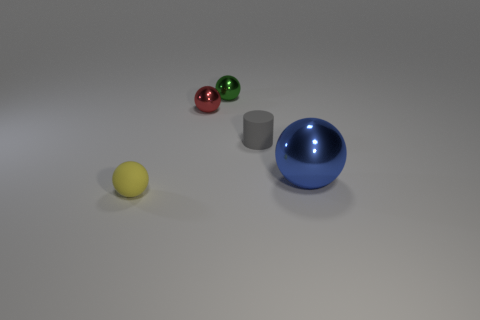There is a object that is in front of the tiny green ball and behind the small gray rubber thing; what is its shape?
Offer a terse response. Sphere. Is there a blue shiny sphere that has the same size as the red metallic sphere?
Keep it short and to the point. No. Do the rubber thing behind the tiny rubber ball and the tiny yellow object have the same shape?
Provide a short and direct response. No. Do the large blue metal thing and the small gray rubber object have the same shape?
Your response must be concise. No. Is there a small brown metallic object of the same shape as the large shiny thing?
Your answer should be very brief. No. What shape is the metal object that is in front of the tiny matte thing that is right of the tiny yellow rubber ball?
Keep it short and to the point. Sphere. What color is the rubber object that is in front of the big metal ball?
Offer a very short reply. Yellow. There is a blue object that is the same material as the tiny green sphere; what size is it?
Your answer should be compact. Large. The red thing that is the same shape as the green object is what size?
Your answer should be compact. Small. Is there a metal thing?
Provide a succinct answer. Yes. 